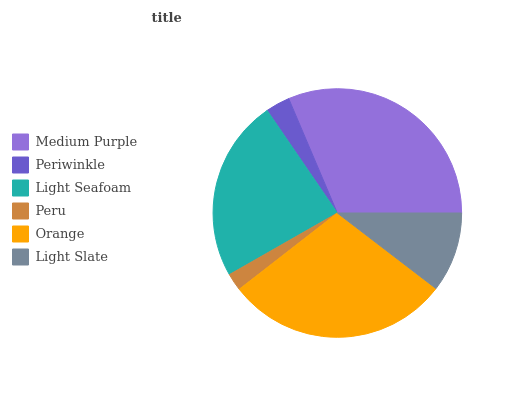Is Peru the minimum?
Answer yes or no. Yes. Is Medium Purple the maximum?
Answer yes or no. Yes. Is Periwinkle the minimum?
Answer yes or no. No. Is Periwinkle the maximum?
Answer yes or no. No. Is Medium Purple greater than Periwinkle?
Answer yes or no. Yes. Is Periwinkle less than Medium Purple?
Answer yes or no. Yes. Is Periwinkle greater than Medium Purple?
Answer yes or no. No. Is Medium Purple less than Periwinkle?
Answer yes or no. No. Is Light Seafoam the high median?
Answer yes or no. Yes. Is Light Slate the low median?
Answer yes or no. Yes. Is Periwinkle the high median?
Answer yes or no. No. Is Periwinkle the low median?
Answer yes or no. No. 